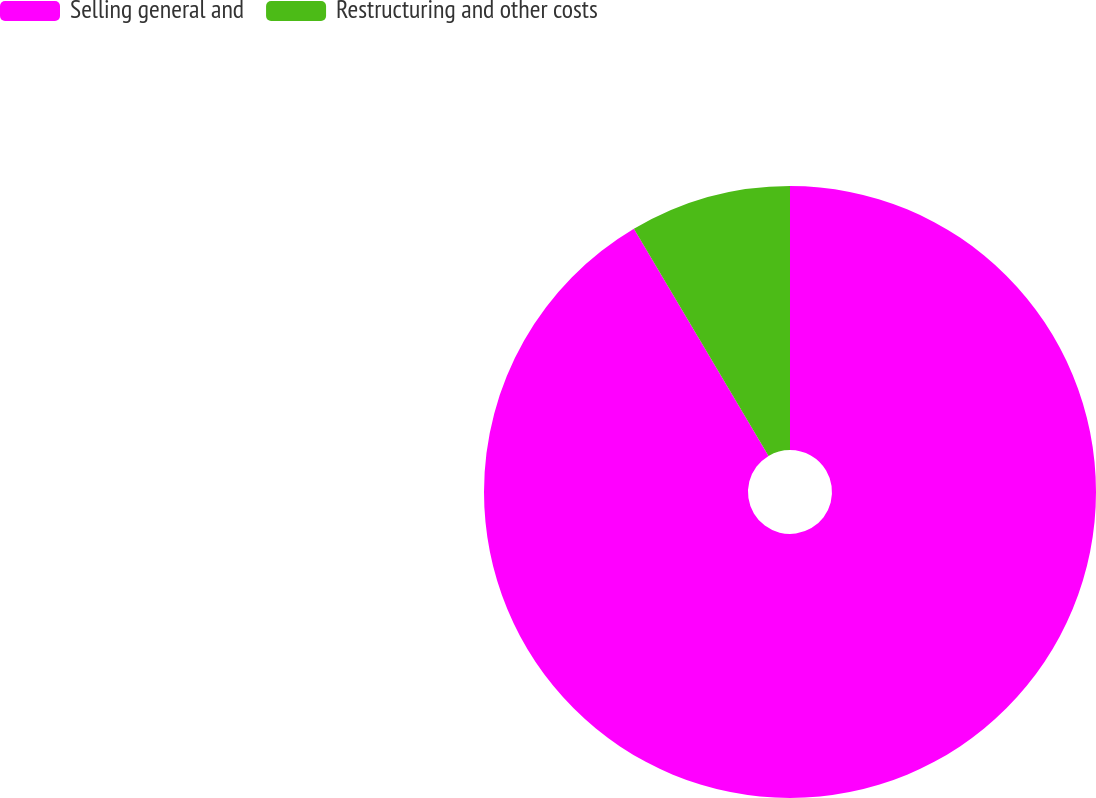<chart> <loc_0><loc_0><loc_500><loc_500><pie_chart><fcel>Selling general and<fcel>Restructuring and other costs<nl><fcel>91.48%<fcel>8.52%<nl></chart> 